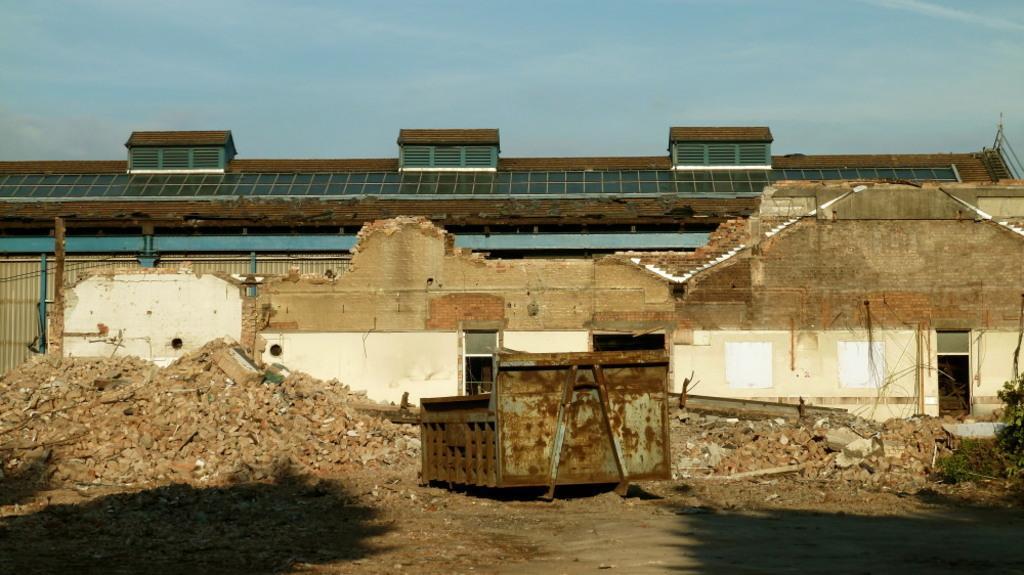Can you describe this image briefly? In this image in the center there is a building and a wall, and some bricks, poles, metal objects, sand and grass. At the bottom there is walkway, and in the background there is a roof and windows, and at the top of the image there is sky. 